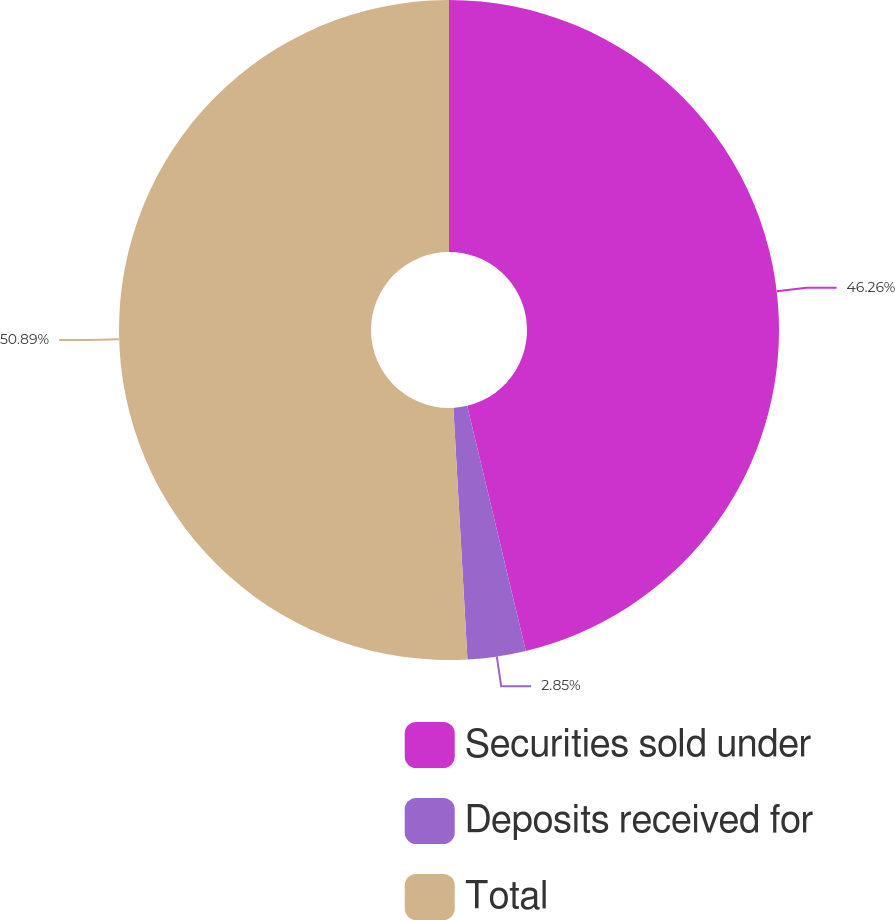<chart> <loc_0><loc_0><loc_500><loc_500><pie_chart><fcel>Securities sold under<fcel>Deposits received for<fcel>Total<nl><fcel>46.26%<fcel>2.85%<fcel>50.89%<nl></chart> 